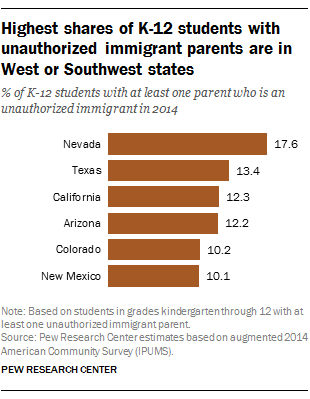Specify some key components in this picture. The difference in the value of the longest bar and the smallest bar is 7.5. The smallest bar has a value of 10.1 